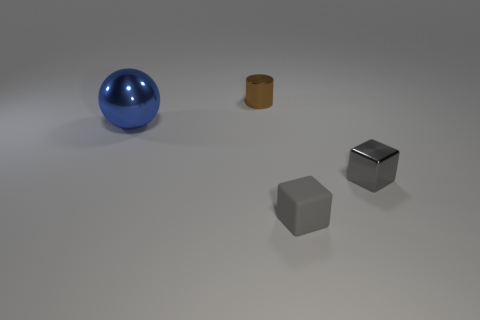Add 1 gray metal things. How many objects exist? 5 Subtract all cylinders. How many objects are left? 3 Subtract 0 gray spheres. How many objects are left? 4 Subtract all big blue balls. Subtract all small gray metal blocks. How many objects are left? 2 Add 4 rubber things. How many rubber things are left? 5 Add 1 tiny gray blocks. How many tiny gray blocks exist? 3 